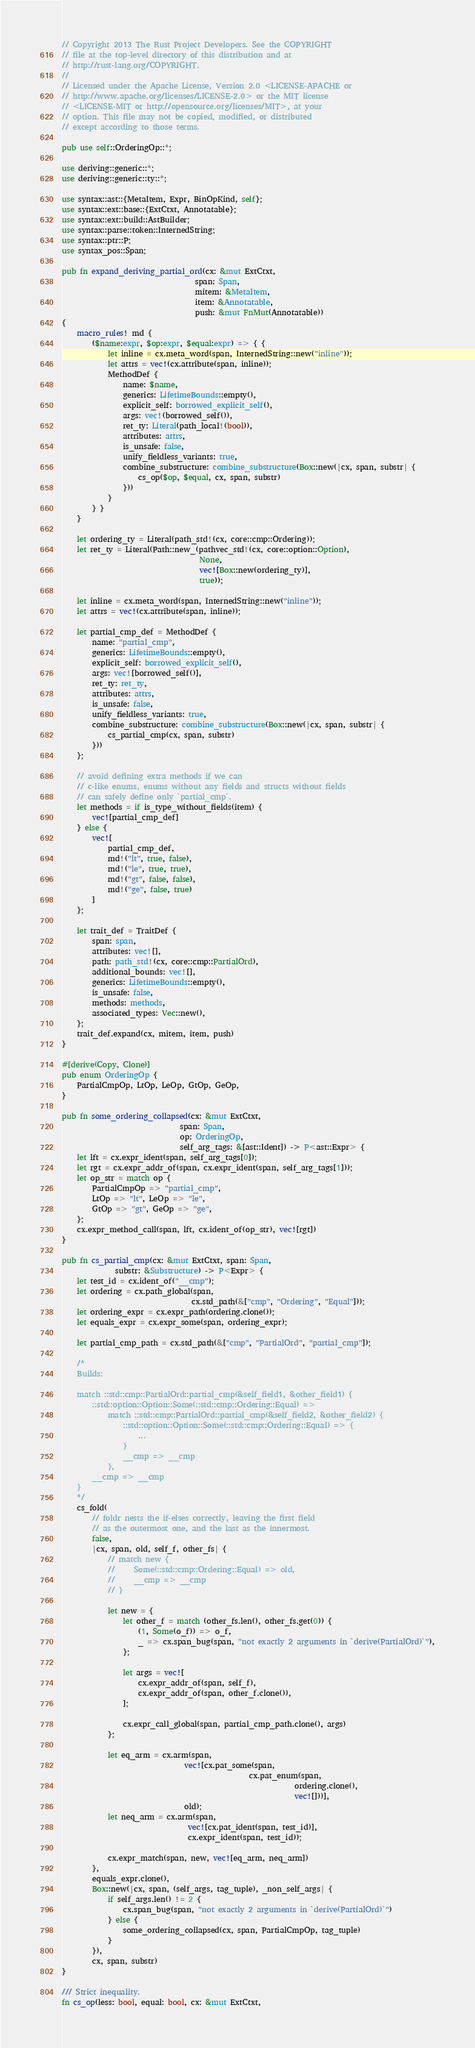Convert code to text. <code><loc_0><loc_0><loc_500><loc_500><_Rust_>// Copyright 2013 The Rust Project Developers. See the COPYRIGHT
// file at the top-level directory of this distribution and at
// http://rust-lang.org/COPYRIGHT.
//
// Licensed under the Apache License, Version 2.0 <LICENSE-APACHE or
// http://www.apache.org/licenses/LICENSE-2.0> or the MIT license
// <LICENSE-MIT or http://opensource.org/licenses/MIT>, at your
// option. This file may not be copied, modified, or distributed
// except according to those terms.

pub use self::OrderingOp::*;

use deriving::generic::*;
use deriving::generic::ty::*;

use syntax::ast::{MetaItem, Expr, BinOpKind, self};
use syntax::ext::base::{ExtCtxt, Annotatable};
use syntax::ext::build::AstBuilder;
use syntax::parse::token::InternedString;
use syntax::ptr::P;
use syntax_pos::Span;

pub fn expand_deriving_partial_ord(cx: &mut ExtCtxt,
                                   span: Span,
                                   mitem: &MetaItem,
                                   item: &Annotatable,
                                   push: &mut FnMut(Annotatable))
{
    macro_rules! md {
        ($name:expr, $op:expr, $equal:expr) => { {
            let inline = cx.meta_word(span, InternedString::new("inline"));
            let attrs = vec!(cx.attribute(span, inline));
            MethodDef {
                name: $name,
                generics: LifetimeBounds::empty(),
                explicit_self: borrowed_explicit_self(),
                args: vec!(borrowed_self()),
                ret_ty: Literal(path_local!(bool)),
                attributes: attrs,
                is_unsafe: false,
                unify_fieldless_variants: true,
                combine_substructure: combine_substructure(Box::new(|cx, span, substr| {
                    cs_op($op, $equal, cx, span, substr)
                }))
            }
        } }
    }

    let ordering_ty = Literal(path_std!(cx, core::cmp::Ordering));
    let ret_ty = Literal(Path::new_(pathvec_std!(cx, core::option::Option),
                                    None,
                                    vec![Box::new(ordering_ty)],
                                    true));

    let inline = cx.meta_word(span, InternedString::new("inline"));
    let attrs = vec!(cx.attribute(span, inline));

    let partial_cmp_def = MethodDef {
        name: "partial_cmp",
        generics: LifetimeBounds::empty(),
        explicit_self: borrowed_explicit_self(),
        args: vec![borrowed_self()],
        ret_ty: ret_ty,
        attributes: attrs,
        is_unsafe: false,
        unify_fieldless_variants: true,
        combine_substructure: combine_substructure(Box::new(|cx, span, substr| {
            cs_partial_cmp(cx, span, substr)
        }))
    };

    // avoid defining extra methods if we can
    // c-like enums, enums without any fields and structs without fields
    // can safely define only `partial_cmp`.
    let methods = if is_type_without_fields(item) {
        vec![partial_cmp_def]
    } else {
        vec![
            partial_cmp_def,
            md!("lt", true, false),
            md!("le", true, true),
            md!("gt", false, false),
            md!("ge", false, true)
        ]
    };

    let trait_def = TraitDef {
        span: span,
        attributes: vec![],
        path: path_std!(cx, core::cmp::PartialOrd),
        additional_bounds: vec![],
        generics: LifetimeBounds::empty(),
        is_unsafe: false,
        methods: methods,
        associated_types: Vec::new(),
    };
    trait_def.expand(cx, mitem, item, push)
}

#[derive(Copy, Clone)]
pub enum OrderingOp {
    PartialCmpOp, LtOp, LeOp, GtOp, GeOp,
}

pub fn some_ordering_collapsed(cx: &mut ExtCtxt,
                               span: Span,
                               op: OrderingOp,
                               self_arg_tags: &[ast::Ident]) -> P<ast::Expr> {
    let lft = cx.expr_ident(span, self_arg_tags[0]);
    let rgt = cx.expr_addr_of(span, cx.expr_ident(span, self_arg_tags[1]));
    let op_str = match op {
        PartialCmpOp => "partial_cmp",
        LtOp => "lt", LeOp => "le",
        GtOp => "gt", GeOp => "ge",
    };
    cx.expr_method_call(span, lft, cx.ident_of(op_str), vec![rgt])
}

pub fn cs_partial_cmp(cx: &mut ExtCtxt, span: Span,
              substr: &Substructure) -> P<Expr> {
    let test_id = cx.ident_of("__cmp");
    let ordering = cx.path_global(span,
                                  cx.std_path(&["cmp", "Ordering", "Equal"]));
    let ordering_expr = cx.expr_path(ordering.clone());
    let equals_expr = cx.expr_some(span, ordering_expr);

    let partial_cmp_path = cx.std_path(&["cmp", "PartialOrd", "partial_cmp"]);

    /*
    Builds:

    match ::std::cmp::PartialOrd::partial_cmp(&self_field1, &other_field1) {
        ::std::option::Option::Some(::std::cmp::Ordering::Equal) =>
            match ::std::cmp::PartialOrd::partial_cmp(&self_field2, &other_field2) {
                ::std::option::Option::Some(::std::cmp::Ordering::Equal) => {
                    ...
                }
                __cmp => __cmp
            },
        __cmp => __cmp
    }
    */
    cs_fold(
        // foldr nests the if-elses correctly, leaving the first field
        // as the outermost one, and the last as the innermost.
        false,
        |cx, span, old, self_f, other_fs| {
            // match new {
            //     Some(::std::cmp::Ordering::Equal) => old,
            //     __cmp => __cmp
            // }

            let new = {
                let other_f = match (other_fs.len(), other_fs.get(0)) {
                    (1, Some(o_f)) => o_f,
                    _ => cx.span_bug(span, "not exactly 2 arguments in `derive(PartialOrd)`"),
                };

                let args = vec![
                    cx.expr_addr_of(span, self_f),
                    cx.expr_addr_of(span, other_f.clone()),
                ];

                cx.expr_call_global(span, partial_cmp_path.clone(), args)
            };

            let eq_arm = cx.arm(span,
                                vec![cx.pat_some(span,
                                                 cx.pat_enum(span,
                                                             ordering.clone(),
                                                             vec![]))],
                                old);
            let neq_arm = cx.arm(span,
                                 vec![cx.pat_ident(span, test_id)],
                                 cx.expr_ident(span, test_id));

            cx.expr_match(span, new, vec![eq_arm, neq_arm])
        },
        equals_expr.clone(),
        Box::new(|cx, span, (self_args, tag_tuple), _non_self_args| {
            if self_args.len() != 2 {
                cx.span_bug(span, "not exactly 2 arguments in `derive(PartialOrd)`")
            } else {
                some_ordering_collapsed(cx, span, PartialCmpOp, tag_tuple)
            }
        }),
        cx, span, substr)
}

/// Strict inequality.
fn cs_op(less: bool, equal: bool, cx: &mut ExtCtxt,</code> 